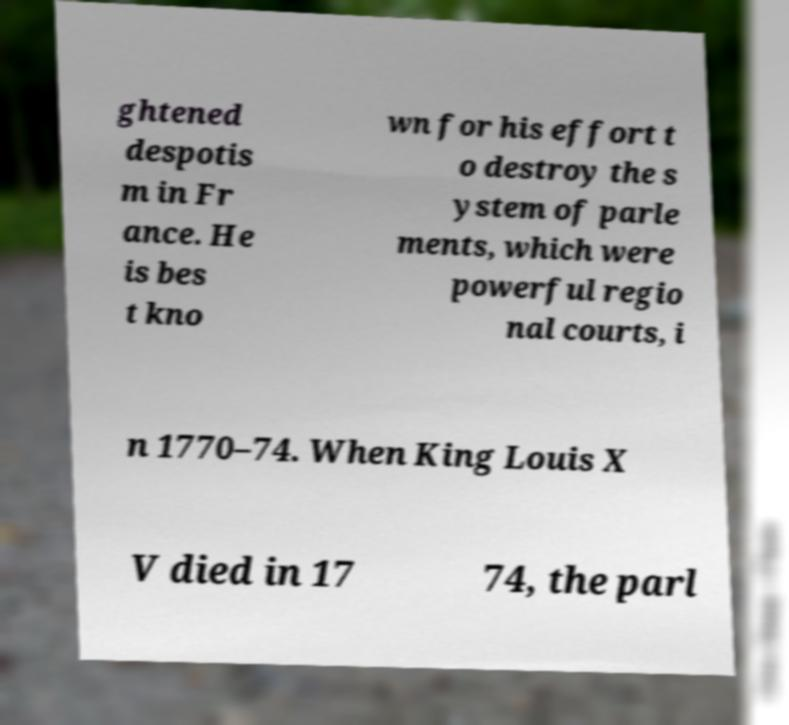Can you accurately transcribe the text from the provided image for me? ghtened despotis m in Fr ance. He is bes t kno wn for his effort t o destroy the s ystem of parle ments, which were powerful regio nal courts, i n 1770–74. When King Louis X V died in 17 74, the parl 